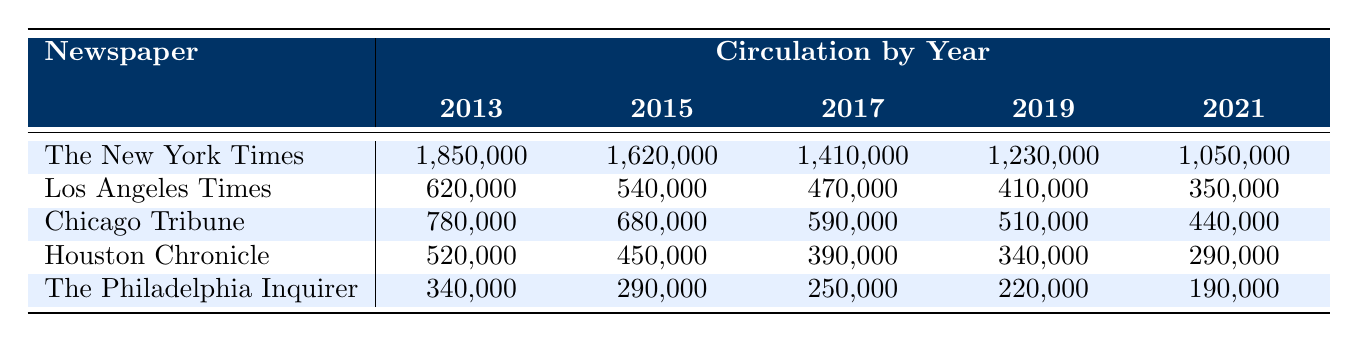What was the circulation of The New York Times in 2013? The table shows that the circulation of The New York Times in 2013 is listed under the year 2013 in its row. The value is 1,850,000.
Answer: 1,850,000 Which newspaper had the highest circulation in 2019? In the 2019 column, we look at the values for all newspapers. The highest value is 1,230,000 for The New York Times.
Answer: The New York Times What is the total circulation of newspapers in Houston over the years listed? To find the total circulation of newspapers in Houston, we sum the values for Houston Chronicle: 520,000 + 450,000 + 390,000 + 340,000 + 290,000 = 1,990,000.
Answer: 1,990,000 Has the circulation of The Philadelphia Inquirer decreased every year? Checking the values for The Philadelphia Inquirer, we see that the circulations in years are: 340,000, 290,000, 250,000, 220,000, 190,000. Each subsequent year shows a decrease.
Answer: Yes What is the average circulation for Chicago Tribune over the decade? The values for Chicago Tribune are: 780,000, 680,000, 590,000, 510,000, and 440,000. First, we sum them: 780,000 + 680,000 + 590,000 + 510,000 + 440,000 = 3,000,000. Then we divide by 5 years: 3,000,000 / 5 = 600,000.
Answer: 600,000 What is the difference in circulation for Los Angeles Times between 2013 and 2021? The circulation for Los Angeles Times in 2013 is 620,000 and in 2021 is 350,000. We find the difference: 620,000 - 350,000 = 270,000.
Answer: 270,000 Which city's newspaper had the lowest circulation in 2021? Looking at the 2021 column, the lowest value is 190,000 for The Philadelphia Inquirer.
Answer: The Philadelphia Inquirer Is there any year where the circulation of newspapers in Chicago was higher than that in Houston? In 2013, Chicago's circulation was 780,000, and Houston's was 520,000. So, Chicago was higher that year. In 2015, it was also higher (680,000 vs. 450,000). For other years, we compare and see Chicago was higher only in 2013 and 2015.
Answer: Yes What percentage decrease did The New York Times experience from 2013 to 2021? The circulation went from 1,850,000 to 1,050,000. The decrease is 1,850,000 - 1,050,000 = 800,000. To find the percentage decrease: (800,000 / 1,850,000) * 100 ≈ 43.24%.
Answer: Approximately 43.24% Which city's newspaper shows the least consistent decrease in circulation over the years? We analyze the circulation data. The Houston Chronicle shows circulations: 520,000, 450,000, 390,000, 340,000, 290,000. Each year is lower, but the decrease isn't as steep as other newspapers compared to total numbers. The New York Times has a high starting number and gradually decreases.
Answer: Houston Chronicle If we combine the circulations of Los Angeles Times and The Philadelphia Inquirer, what would be the total for 2019? The values for 2019 are: Los Angeles Times is 410,000 and The Philadelphia Inquirer is 220,000. Combining these gives 410,000 + 220,000 = 630,000.
Answer: 630,000 